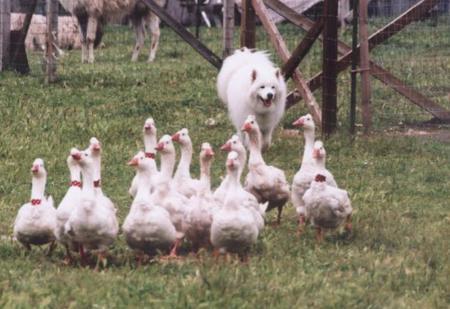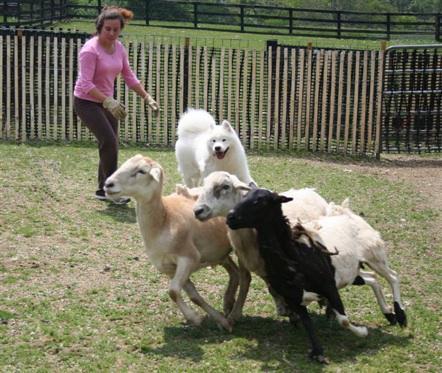The first image is the image on the left, the second image is the image on the right. Evaluate the accuracy of this statement regarding the images: "A woman holding a stick stands behind multiple woolly sheep and is near a white dog.". Is it true? Answer yes or no. No. The first image is the image on the left, the second image is the image on the right. Examine the images to the left and right. Is the description "A woman is standing in the field in only one of the images." accurate? Answer yes or no. Yes. 